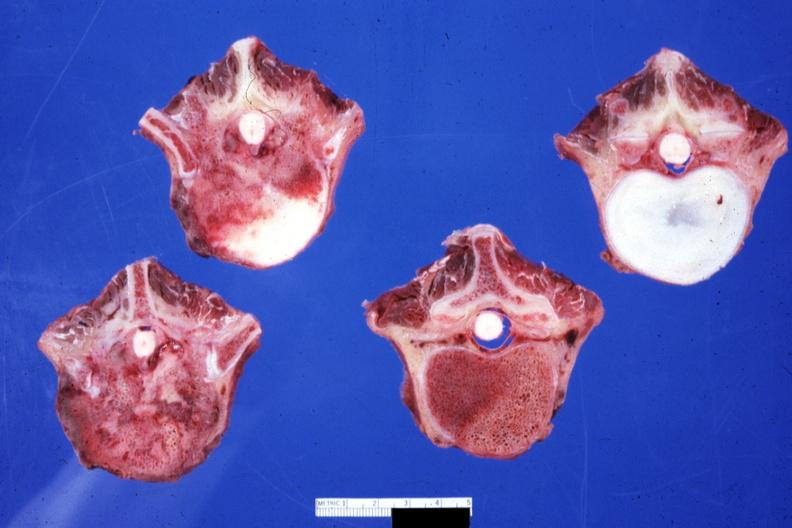what is present?
Answer the question using a single word or phrase. Joints 